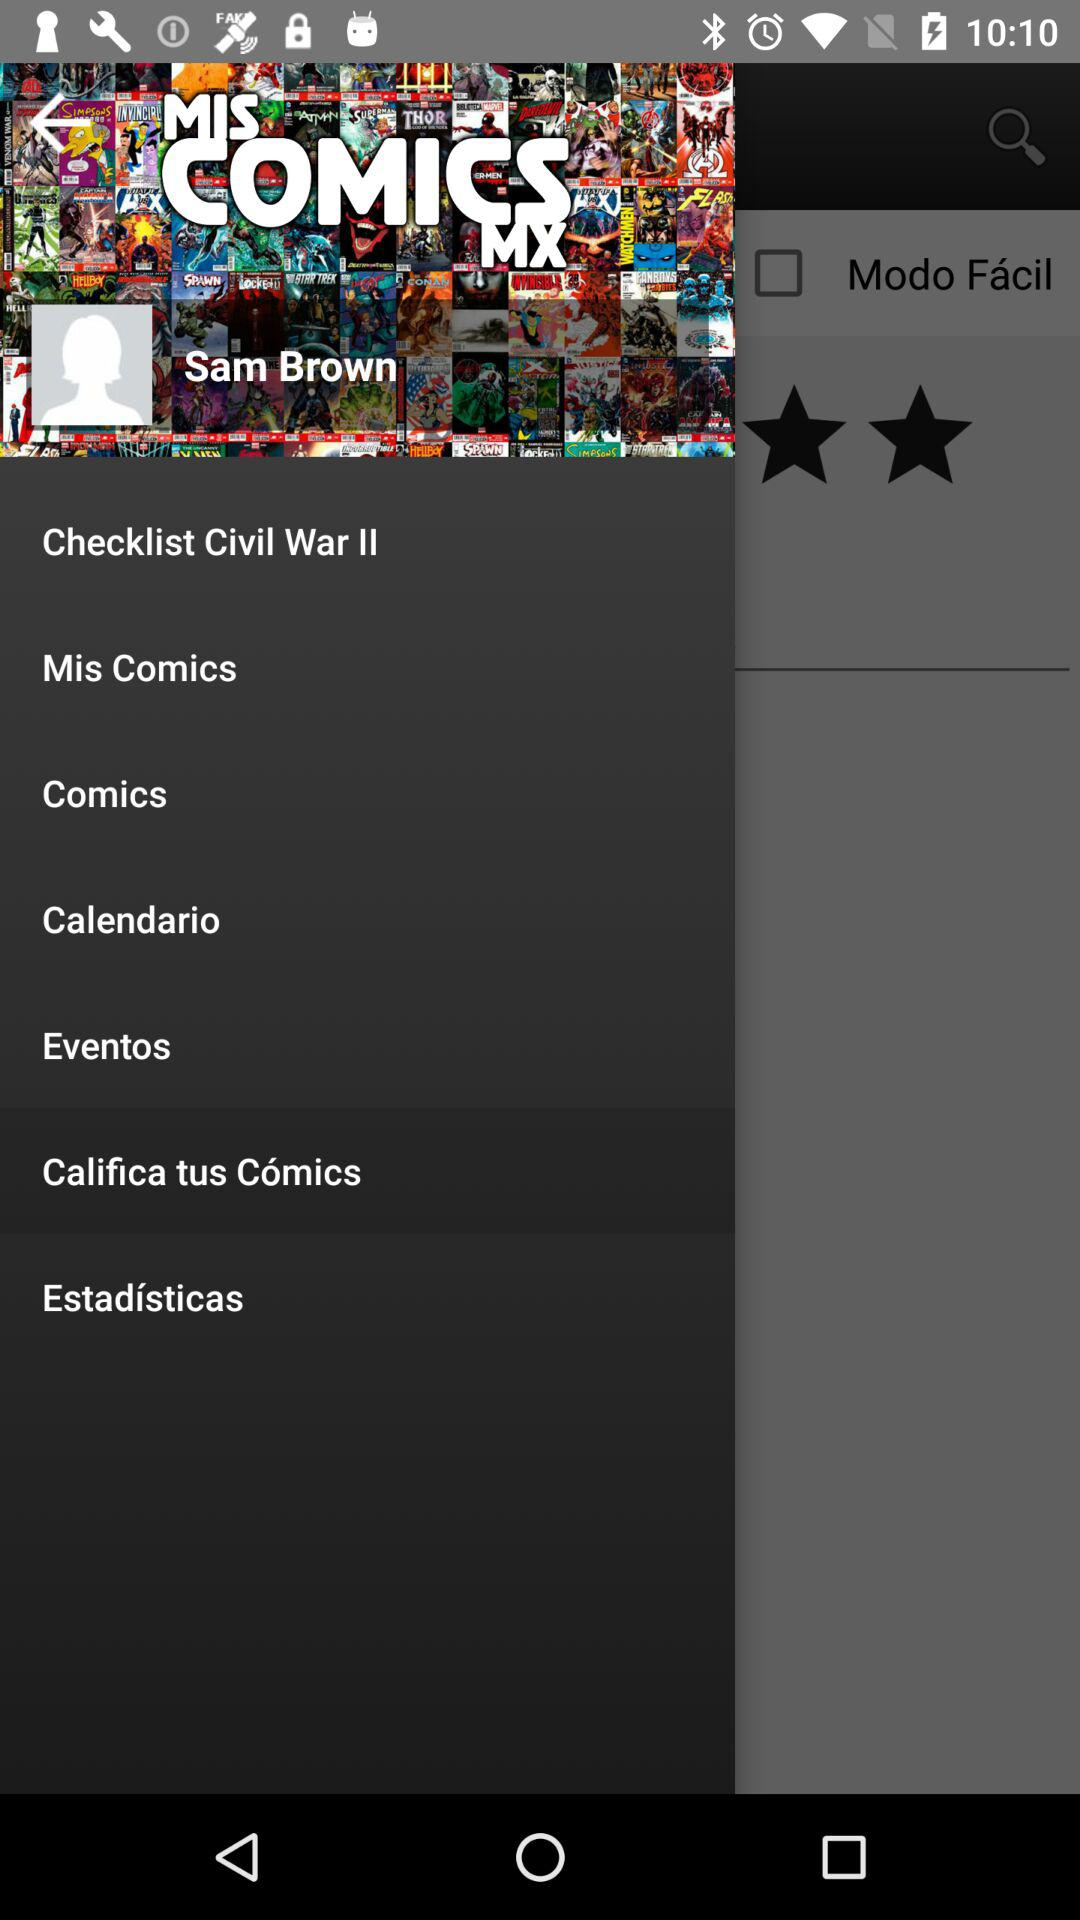What is the user name? The user name is Sam Brown. 